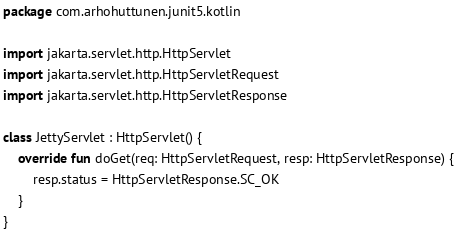<code> <loc_0><loc_0><loc_500><loc_500><_Kotlin_>package com.arhohuttunen.junit5.kotlin

import jakarta.servlet.http.HttpServlet
import jakarta.servlet.http.HttpServletRequest
import jakarta.servlet.http.HttpServletResponse

class JettyServlet : HttpServlet() {
    override fun doGet(req: HttpServletRequest, resp: HttpServletResponse) {
        resp.status = HttpServletResponse.SC_OK
    }
}</code> 